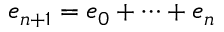<formula> <loc_0><loc_0><loc_500><loc_500>e _ { n + 1 } = e _ { 0 } + \dots + e _ { n }</formula> 